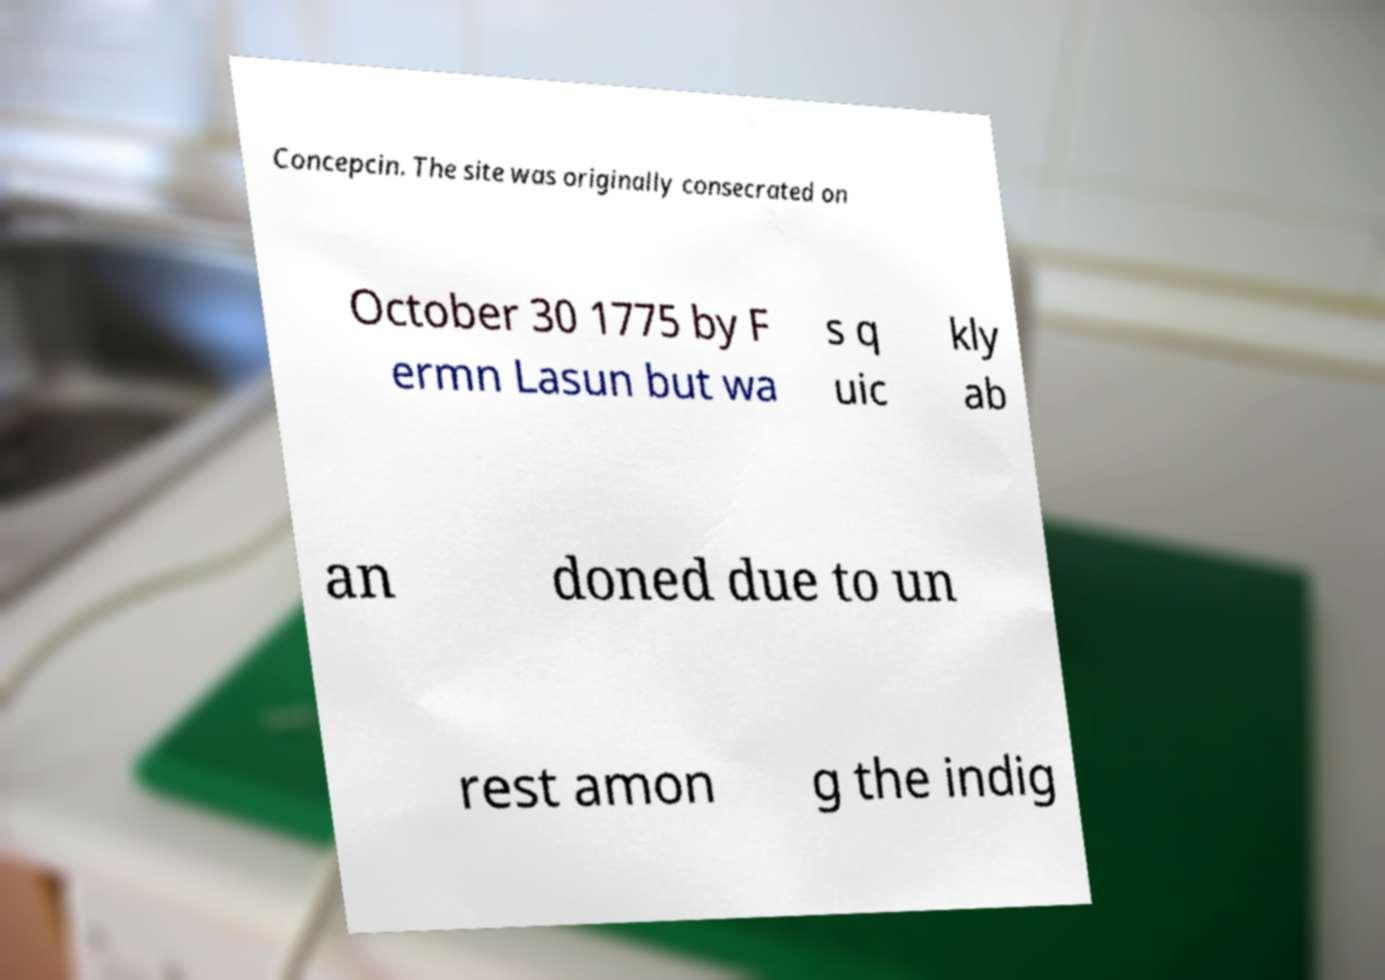Please identify and transcribe the text found in this image. Concepcin. The site was originally consecrated on October 30 1775 by F ermn Lasun but wa s q uic kly ab an doned due to un rest amon g the indig 